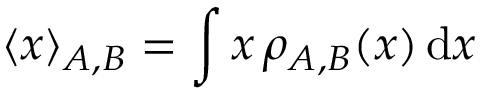<formula> <loc_0><loc_0><loc_500><loc_500>\langle { x } \rangle _ { A , B } = \int { x } \, \rho _ { A , B } ( { x } ) \, d { x }</formula> 